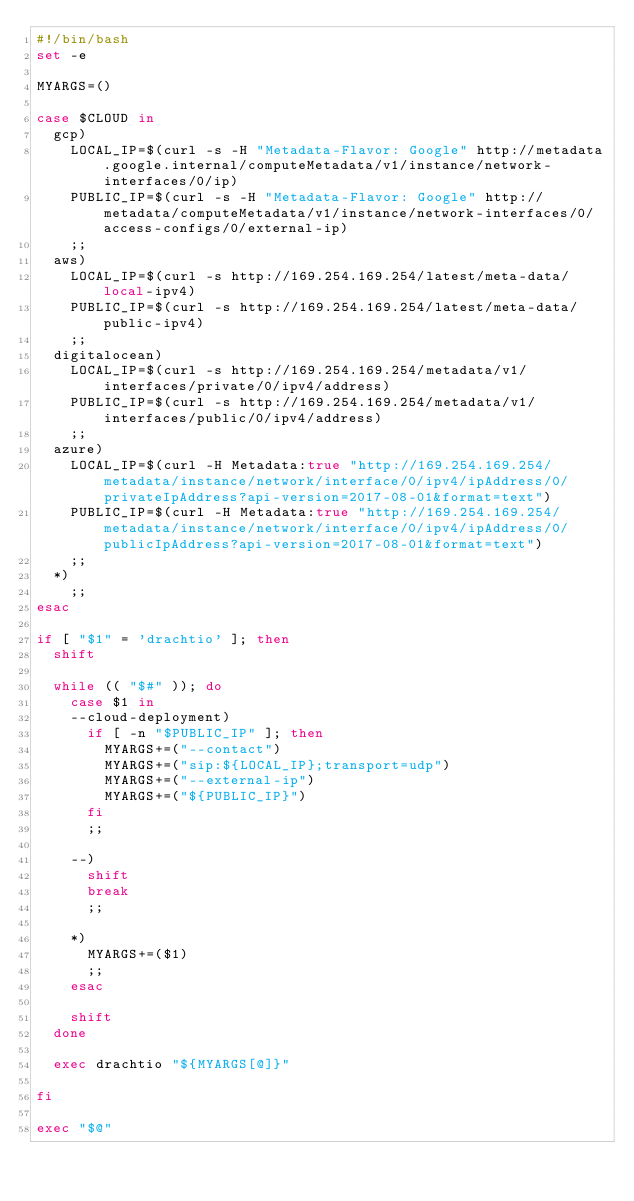<code> <loc_0><loc_0><loc_500><loc_500><_Bash_>#!/bin/bash
set -e

MYARGS=()

case $CLOUD in 
  gcp)
    LOCAL_IP=$(curl -s -H "Metadata-Flavor: Google" http://metadata.google.internal/computeMetadata/v1/instance/network-interfaces/0/ip)
    PUBLIC_IP=$(curl -s -H "Metadata-Flavor: Google" http://metadata/computeMetadata/v1/instance/network-interfaces/0/access-configs/0/external-ip)
    ;;
  aws)
    LOCAL_IP=$(curl -s http://169.254.169.254/latest/meta-data/local-ipv4)
    PUBLIC_IP=$(curl -s http://169.254.169.254/latest/meta-data/public-ipv4)
    ;;
  digitalocean)
    LOCAL_IP=$(curl -s http://169.254.169.254/metadata/v1/interfaces/private/0/ipv4/address)
    PUBLIC_IP=$(curl -s http://169.254.169.254/metadata/v1/interfaces/public/0/ipv4/address)
    ;;
  azure)
    LOCAL_IP=$(curl -H Metadata:true "http://169.254.169.254/metadata/instance/network/interface/0/ipv4/ipAddress/0/privateIpAddress?api-version=2017-08-01&format=text")
    PUBLIC_IP=$(curl -H Metadata:true "http://169.254.169.254/metadata/instance/network/interface/0/ipv4/ipAddress/0/publicIpAddress?api-version=2017-08-01&format=text")
    ;;
  *)
    ;;
esac

if [ "$1" = 'drachtio' ]; then
  shift

  while (( "$#" )); do
    case $1 in
    --cloud-deployment)
      if [ -n "$PUBLIC_IP" ]; then
        MYARGS+=("--contact")
        MYARGS+=("sip:${LOCAL_IP};transport=udp")
        MYARGS+=("--external-ip")
        MYARGS+=("${PUBLIC_IP}")
      fi
      ;;

    --)
      shift
      break
      ;;

    *)
      MYARGS+=($1)
      ;;
    esac

    shift  
  done 
  
  exec drachtio "${MYARGS[@]}"
  
fi

exec "$@"

</code> 